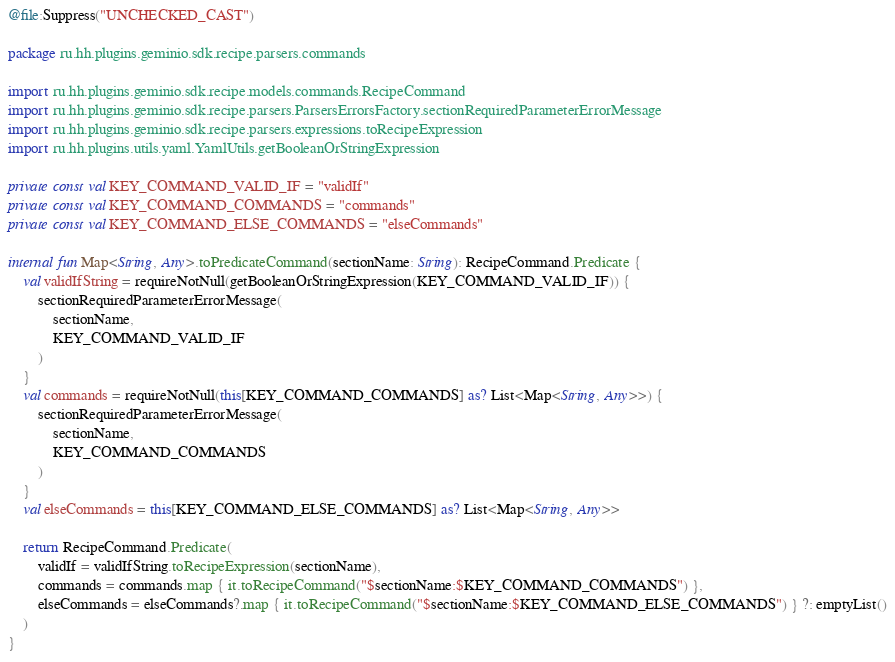<code> <loc_0><loc_0><loc_500><loc_500><_Kotlin_>@file:Suppress("UNCHECKED_CAST")

package ru.hh.plugins.geminio.sdk.recipe.parsers.commands

import ru.hh.plugins.geminio.sdk.recipe.models.commands.RecipeCommand
import ru.hh.plugins.geminio.sdk.recipe.parsers.ParsersErrorsFactory.sectionRequiredParameterErrorMessage
import ru.hh.plugins.geminio.sdk.recipe.parsers.expressions.toRecipeExpression
import ru.hh.plugins.utils.yaml.YamlUtils.getBooleanOrStringExpression

private const val KEY_COMMAND_VALID_IF = "validIf"
private const val KEY_COMMAND_COMMANDS = "commands"
private const val KEY_COMMAND_ELSE_COMMANDS = "elseCommands"

internal fun Map<String, Any>.toPredicateCommand(sectionName: String): RecipeCommand.Predicate {
    val validIfString = requireNotNull(getBooleanOrStringExpression(KEY_COMMAND_VALID_IF)) {
        sectionRequiredParameterErrorMessage(
            sectionName,
            KEY_COMMAND_VALID_IF
        )
    }
    val commands = requireNotNull(this[KEY_COMMAND_COMMANDS] as? List<Map<String, Any>>) {
        sectionRequiredParameterErrorMessage(
            sectionName,
            KEY_COMMAND_COMMANDS
        )
    }
    val elseCommands = this[KEY_COMMAND_ELSE_COMMANDS] as? List<Map<String, Any>>

    return RecipeCommand.Predicate(
        validIf = validIfString.toRecipeExpression(sectionName),
        commands = commands.map { it.toRecipeCommand("$sectionName:$KEY_COMMAND_COMMANDS") },
        elseCommands = elseCommands?.map { it.toRecipeCommand("$sectionName:$KEY_COMMAND_ELSE_COMMANDS") } ?: emptyList()
    )
}
</code> 